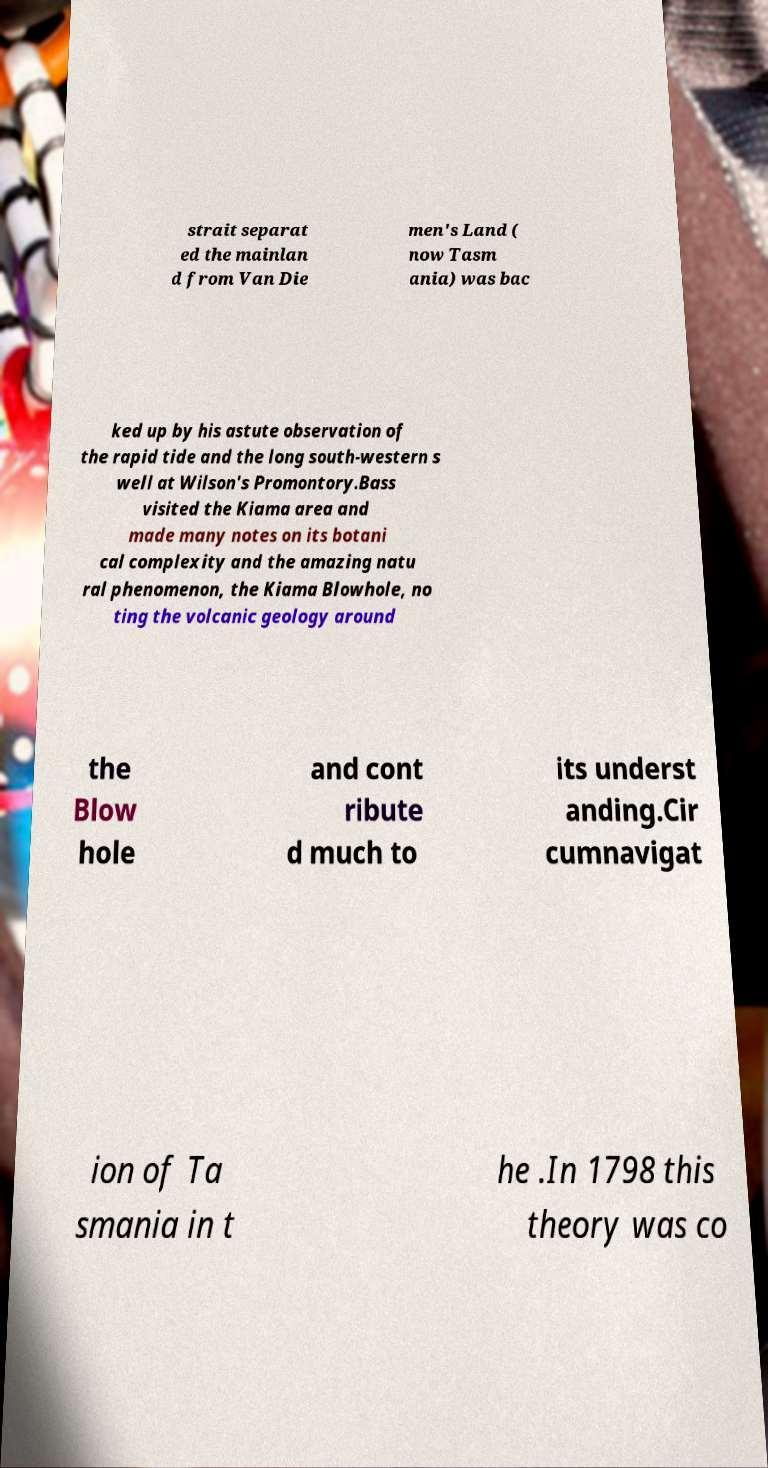Can you read and provide the text displayed in the image?This photo seems to have some interesting text. Can you extract and type it out for me? strait separat ed the mainlan d from Van Die men's Land ( now Tasm ania) was bac ked up by his astute observation of the rapid tide and the long south-western s well at Wilson's Promontory.Bass visited the Kiama area and made many notes on its botani cal complexity and the amazing natu ral phenomenon, the Kiama Blowhole, no ting the volcanic geology around the Blow hole and cont ribute d much to its underst anding.Cir cumnavigat ion of Ta smania in t he .In 1798 this theory was co 